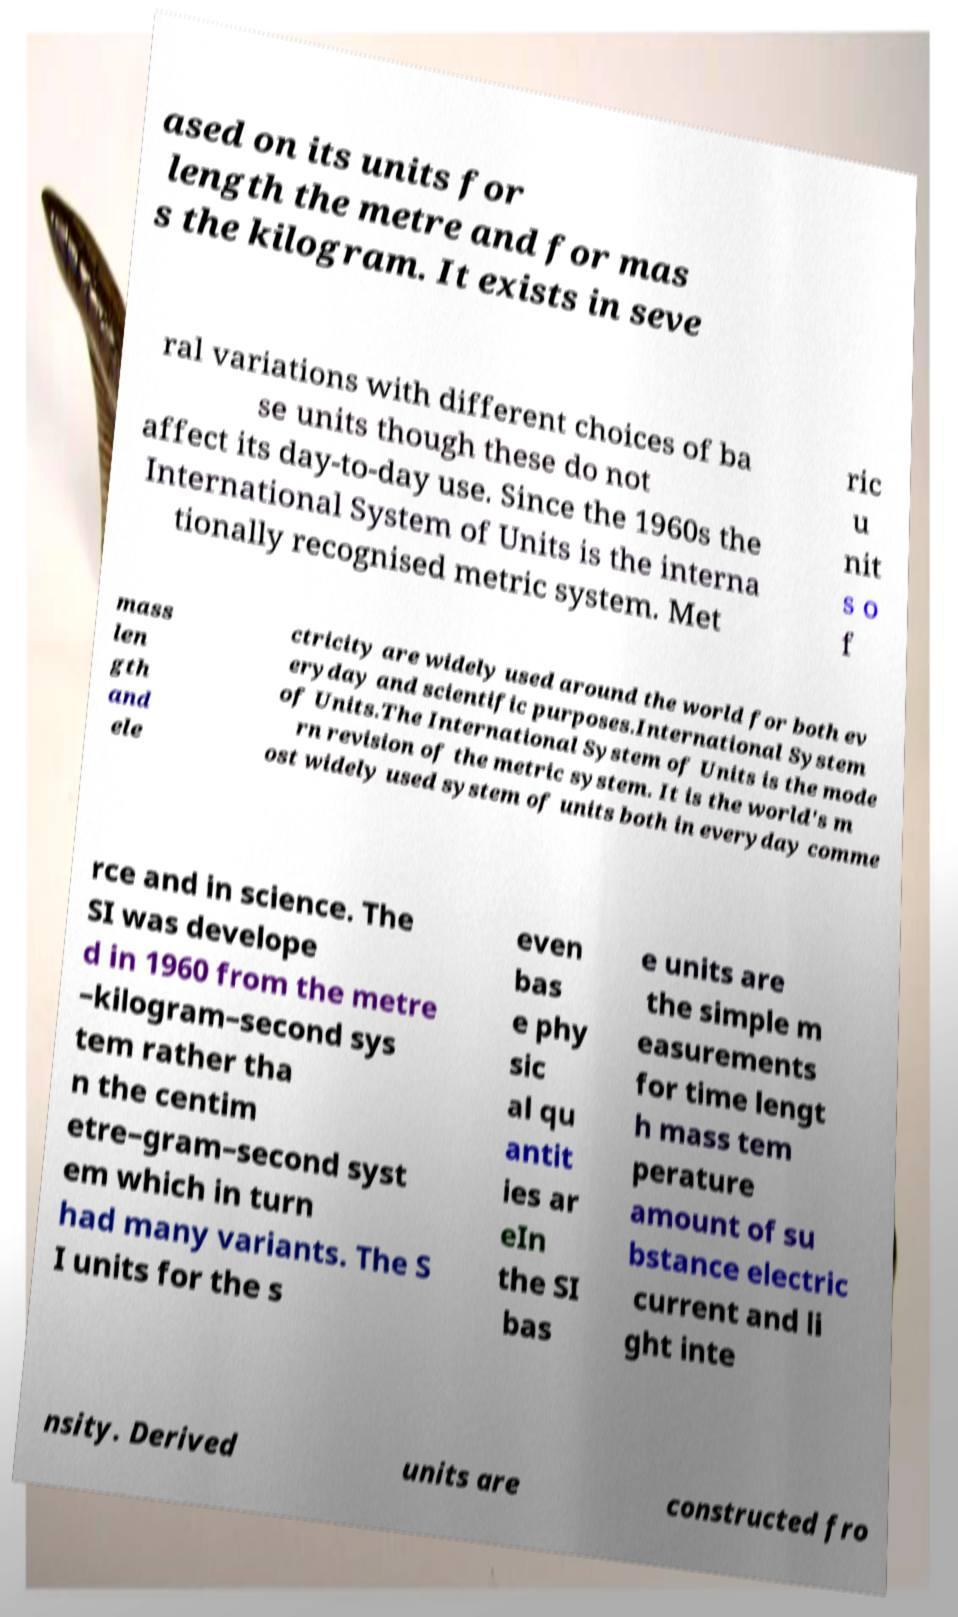Please identify and transcribe the text found in this image. ased on its units for length the metre and for mas s the kilogram. It exists in seve ral variations with different choices of ba se units though these do not affect its day-to-day use. Since the 1960s the International System of Units is the interna tionally recognised metric system. Met ric u nit s o f mass len gth and ele ctricity are widely used around the world for both ev eryday and scientific purposes.International System of Units.The International System of Units is the mode rn revision of the metric system. It is the world's m ost widely used system of units both in everyday comme rce and in science. The SI was develope d in 1960 from the metre –kilogram–second sys tem rather tha n the centim etre–gram–second syst em which in turn had many variants. The S I units for the s even bas e phy sic al qu antit ies ar eIn the SI bas e units are the simple m easurements for time lengt h mass tem perature amount of su bstance electric current and li ght inte nsity. Derived units are constructed fro 